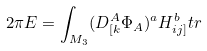<formula> <loc_0><loc_0><loc_500><loc_500>2 \pi E = \int _ { M _ { 3 } } ( D _ { [ k } ^ { A } \Phi _ { A } ) ^ { a } H _ { i j ] } ^ { b } t r</formula> 